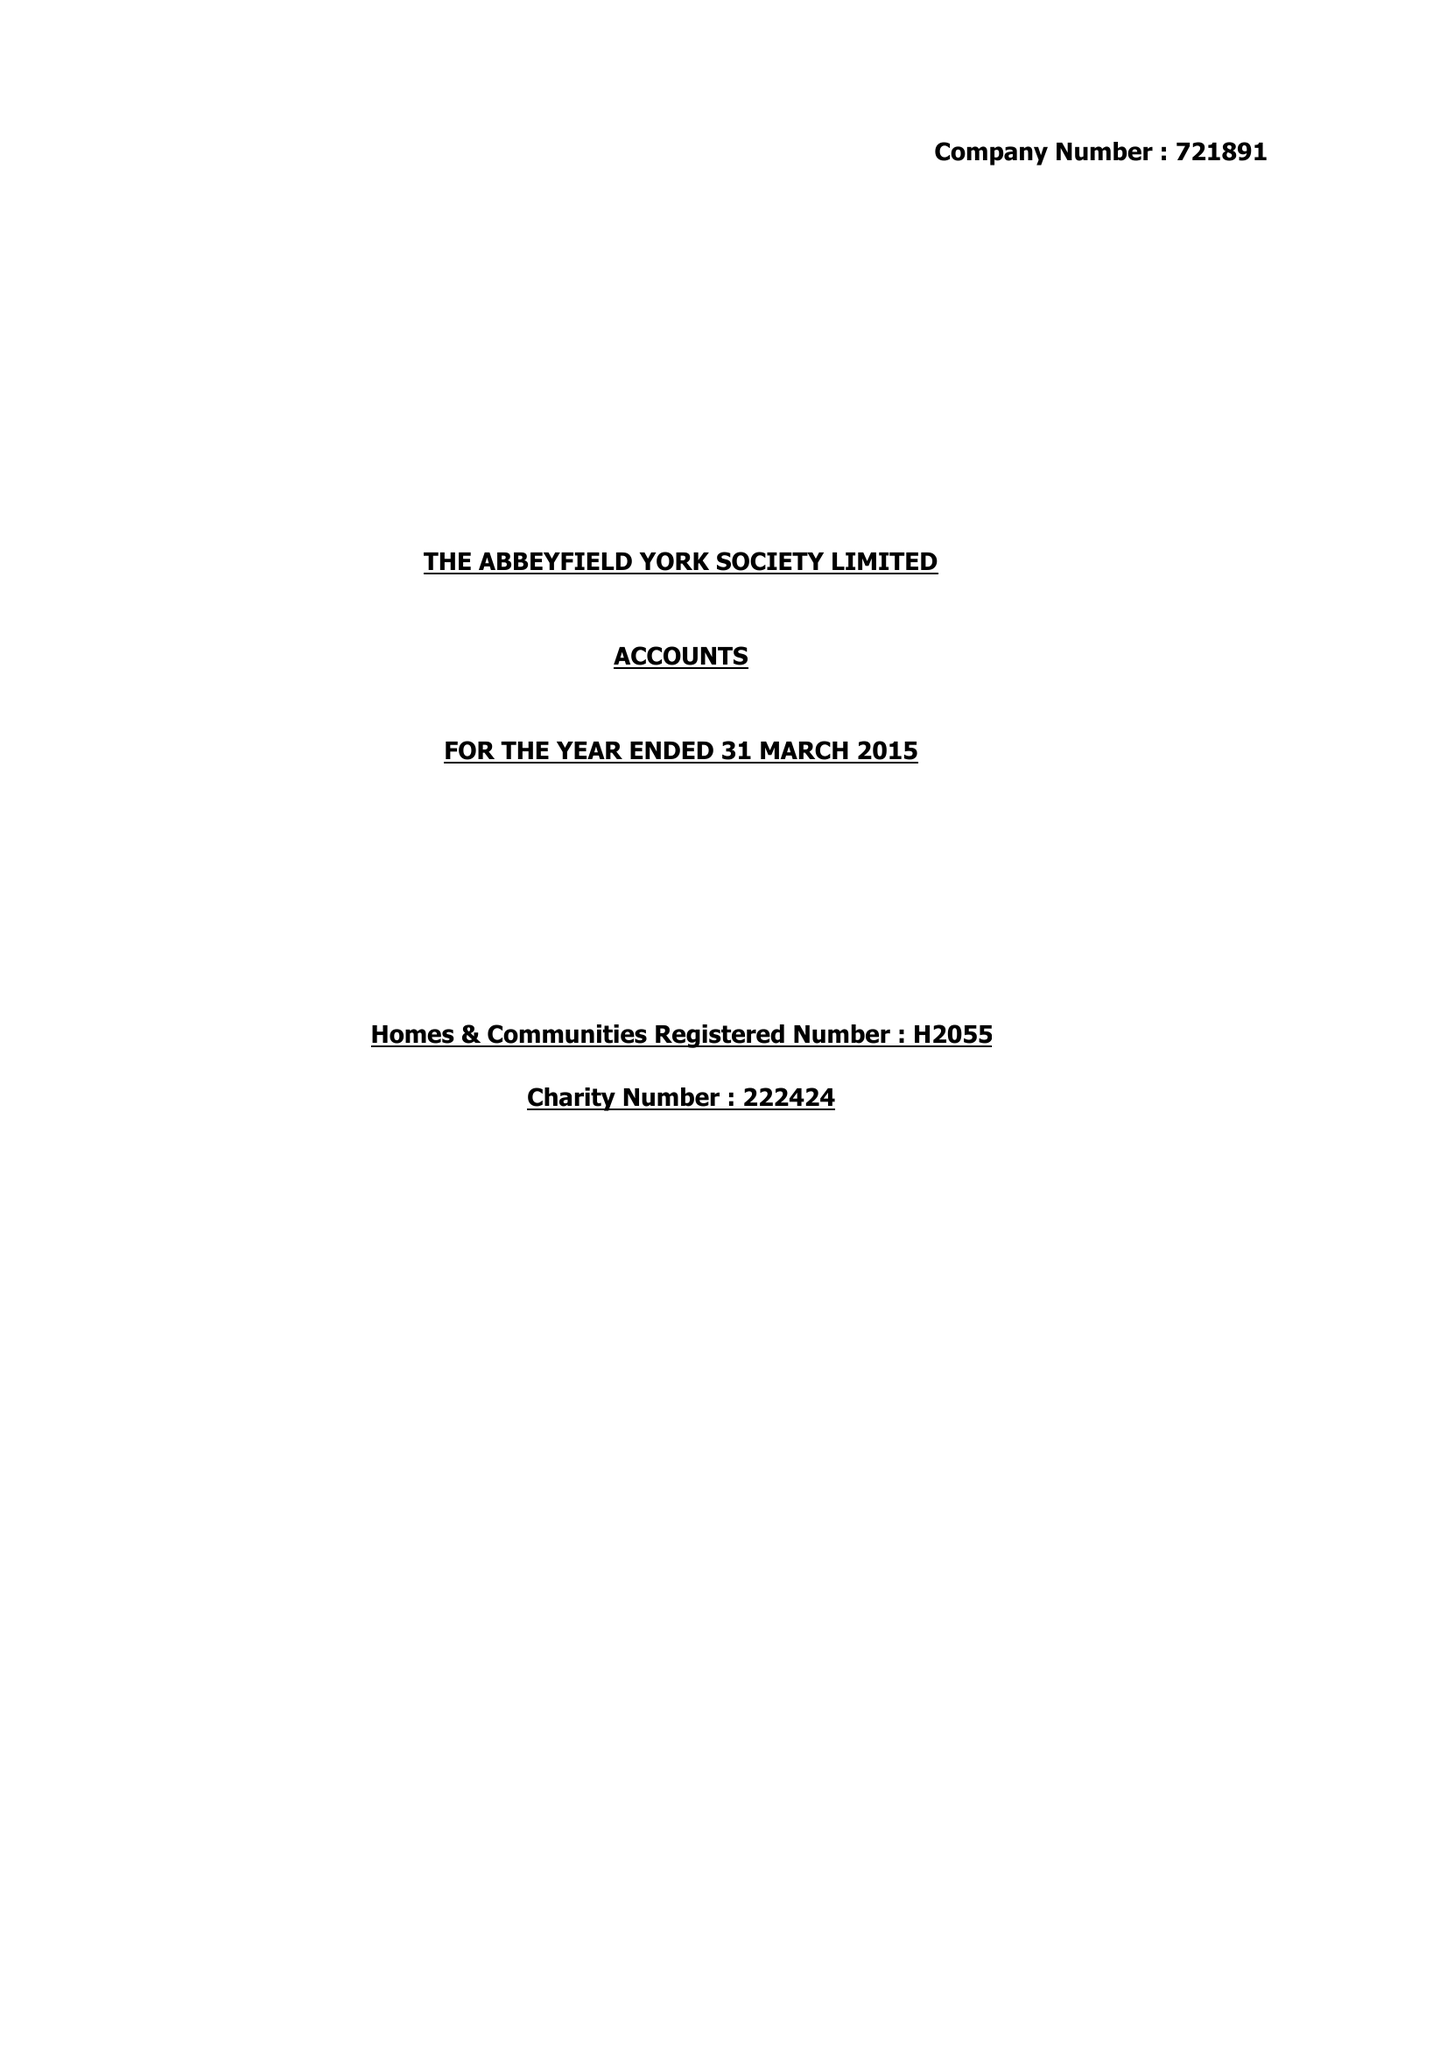What is the value for the address__street_line?
Answer the question using a single word or phrase. None 